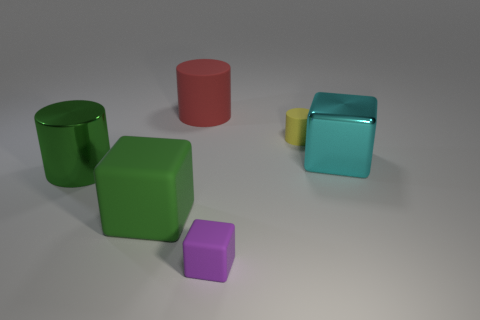How many rubber objects are big yellow cubes or cylinders?
Ensure brevity in your answer.  2. There is another small cylinder that is the same material as the red cylinder; what color is it?
Ensure brevity in your answer.  Yellow. What is the material of the small purple object that is right of the big object behind the cyan metal thing?
Your response must be concise. Rubber. What number of objects are blocks behind the big matte cube or big things on the left side of the large cyan block?
Your response must be concise. 4. There is a green object that is in front of the large green metal object behind the big thing that is in front of the green shiny object; what is its size?
Keep it short and to the point. Large. Are there the same number of tiny blocks in front of the tiny purple matte cube and small rubber cubes?
Offer a very short reply. No. Is there anything else that is the same shape as the red object?
Keep it short and to the point. Yes. Do the red rubber thing and the small rubber object behind the purple object have the same shape?
Keep it short and to the point. Yes. What is the size of the green object that is the same shape as the purple rubber object?
Offer a very short reply. Large. What number of other objects are there of the same material as the red thing?
Provide a short and direct response. 3. 